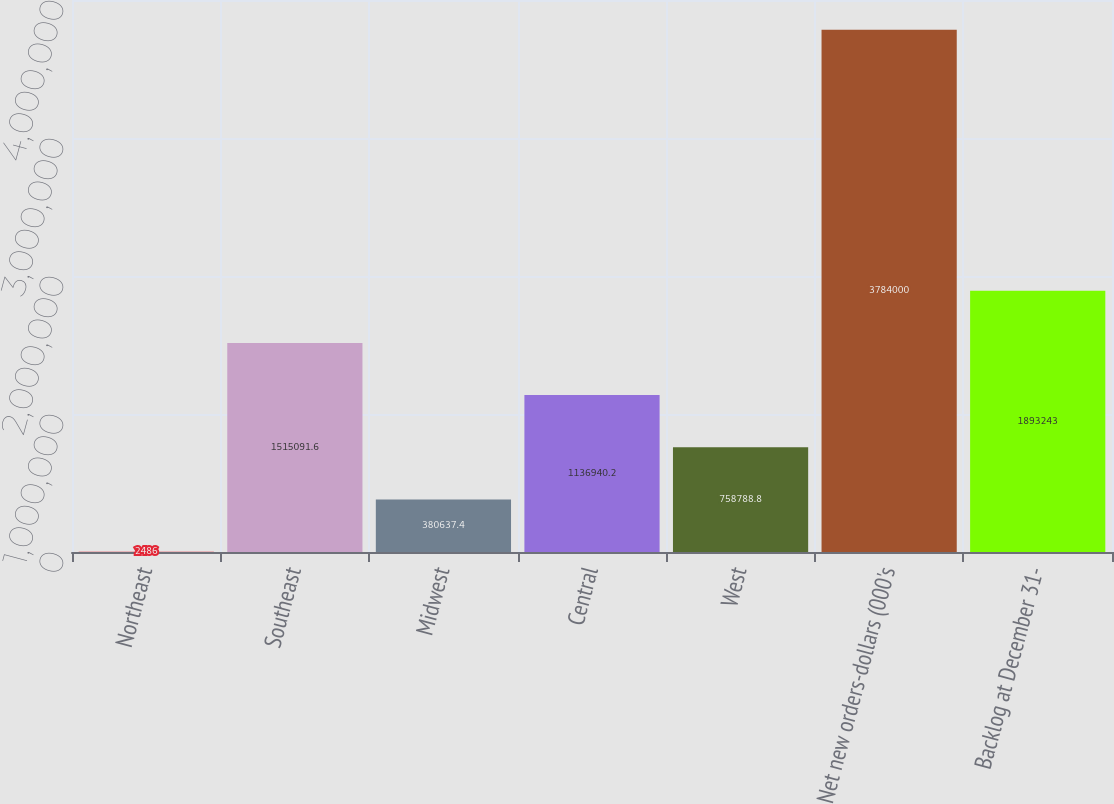Convert chart. <chart><loc_0><loc_0><loc_500><loc_500><bar_chart><fcel>Northeast<fcel>Southeast<fcel>Midwest<fcel>Central<fcel>West<fcel>Net new orders-dollars (000's<fcel>Backlog at December 31-<nl><fcel>2486<fcel>1.51509e+06<fcel>380637<fcel>1.13694e+06<fcel>758789<fcel>3.784e+06<fcel>1.89324e+06<nl></chart> 